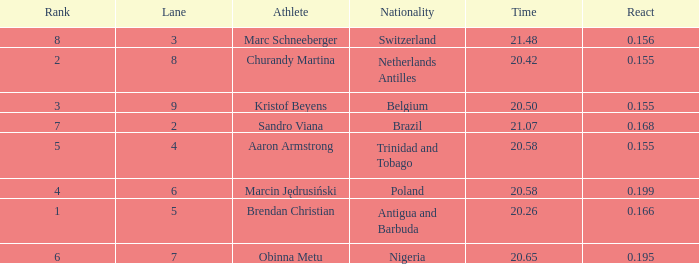Which Lane has a Time larger than 20.5, and a Nationality of trinidad and tobago? 4.0. 